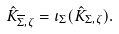<formula> <loc_0><loc_0><loc_500><loc_500>\hat { K } _ { \overline { \Sigma } , \zeta } = \iota _ { \Sigma } ( \hat { K } _ { \Sigma , \zeta } ) .</formula> 